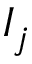<formula> <loc_0><loc_0><loc_500><loc_500>I _ { j }</formula> 